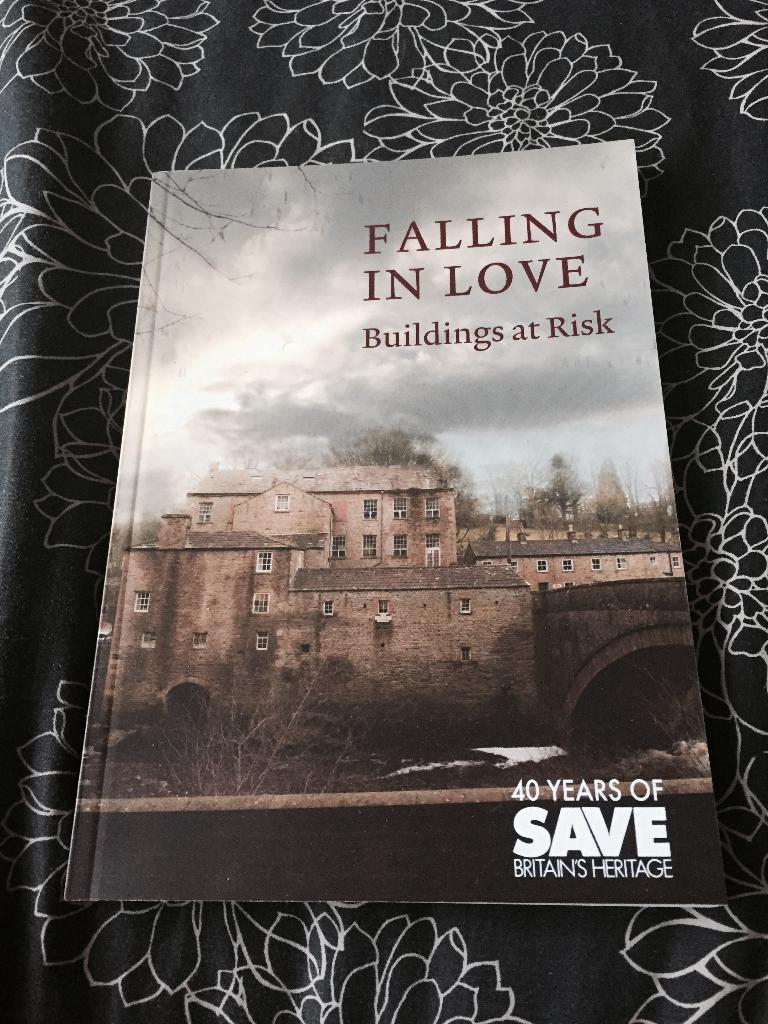How many years of britain's heritage?
Make the answer very short. 40. What is the name of this book?
Offer a very short reply. Falling in love. 